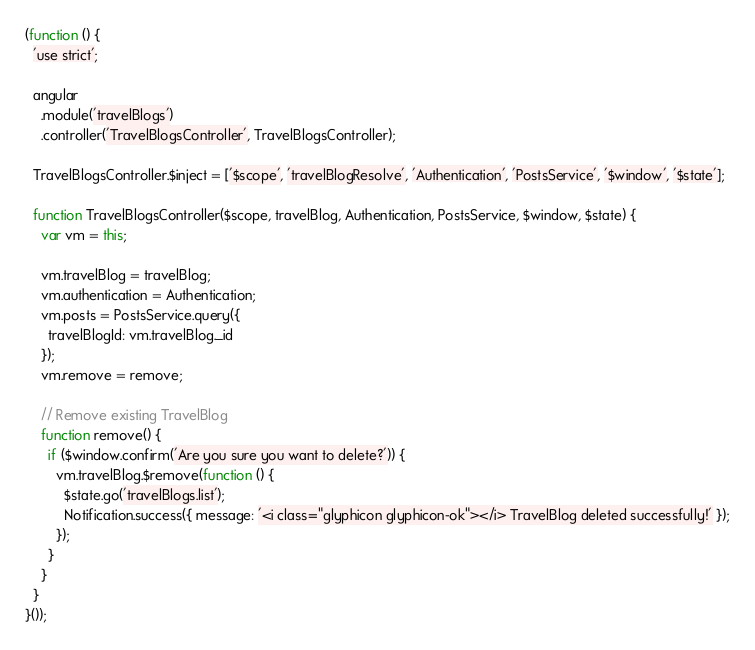Convert code to text. <code><loc_0><loc_0><loc_500><loc_500><_JavaScript_>(function () {
  'use strict';

  angular
    .module('travelBlogs')
    .controller('TravelBlogsController', TravelBlogsController);

  TravelBlogsController.$inject = ['$scope', 'travelBlogResolve', 'Authentication', 'PostsService', '$window', '$state'];

  function TravelBlogsController($scope, travelBlog, Authentication, PostsService, $window, $state) {
    var vm = this;

    vm.travelBlog = travelBlog;
    vm.authentication = Authentication;
    vm.posts = PostsService.query({
      travelBlogId: vm.travelBlog._id
    });
    vm.remove = remove;

    // Remove existing TravelBlog
    function remove() {
      if ($window.confirm('Are you sure you want to delete?')) {
        vm.travelBlog.$remove(function () {
          $state.go('travelBlogs.list');
          Notification.success({ message: '<i class="glyphicon glyphicon-ok"></i> TravelBlog deleted successfully!' });
        });
      }
    }
  }
}());
</code> 